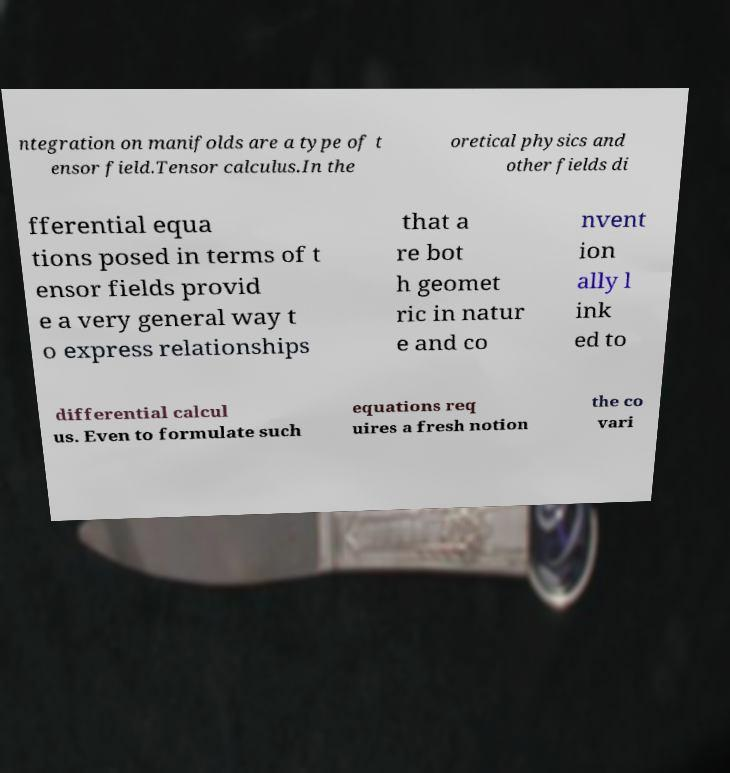For documentation purposes, I need the text within this image transcribed. Could you provide that? ntegration on manifolds are a type of t ensor field.Tensor calculus.In the oretical physics and other fields di fferential equa tions posed in terms of t ensor fields provid e a very general way t o express relationships that a re bot h geomet ric in natur e and co nvent ion ally l ink ed to differential calcul us. Even to formulate such equations req uires a fresh notion the co vari 